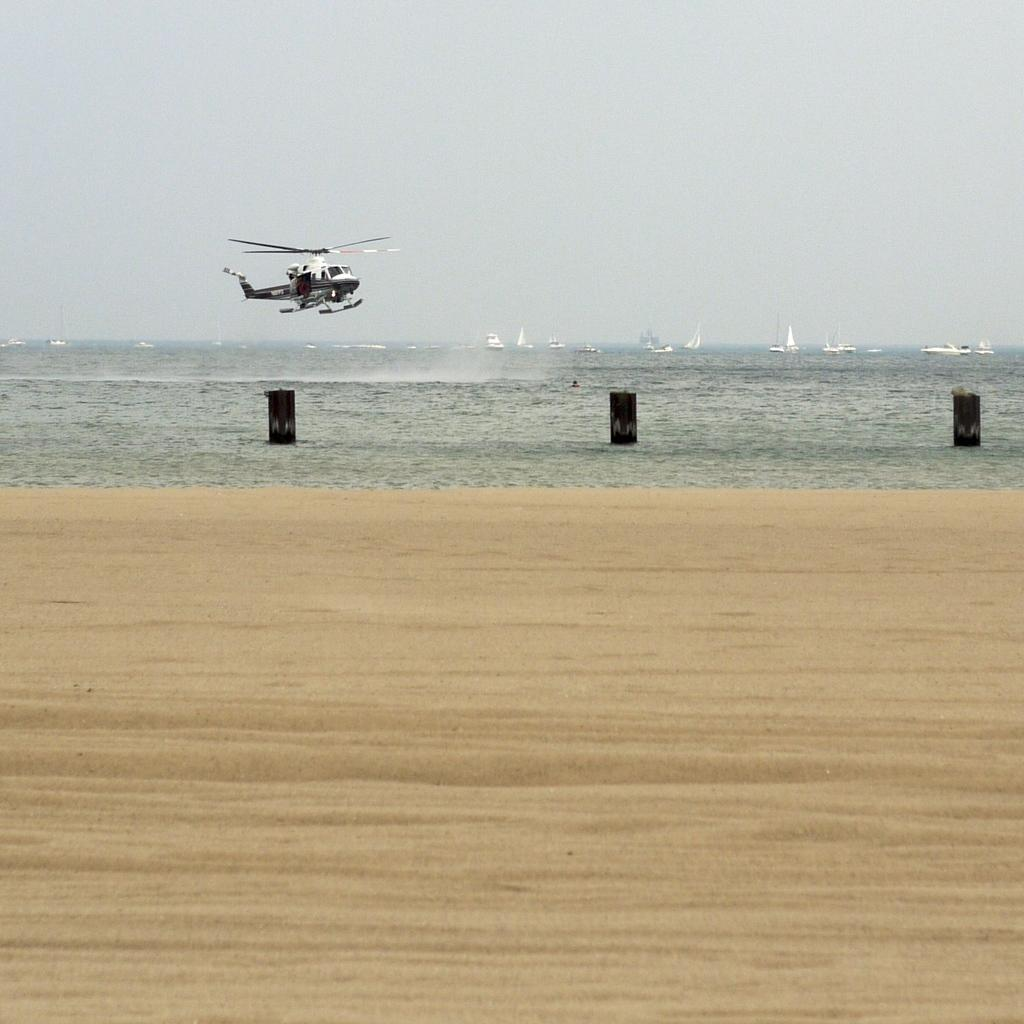What is the main subject of the image? The main subject of the image is a helicopter. What type of terrain can be seen in the image? There is sand visible in the image, suggesting a beach or desert environment. What else is visible in the image besides the helicopter? There is water and a sky visible in the image. What is present in the water? There are boats in the water. What type of haircut is the helicopter getting in the image? There is no haircut being performed in the image, as the subject is a helicopter and not a person. What type of meal is being prepared in the image? There is no meal preparation visible in the image; the focus is on the helicopter, sand, water, sky, and boats. 